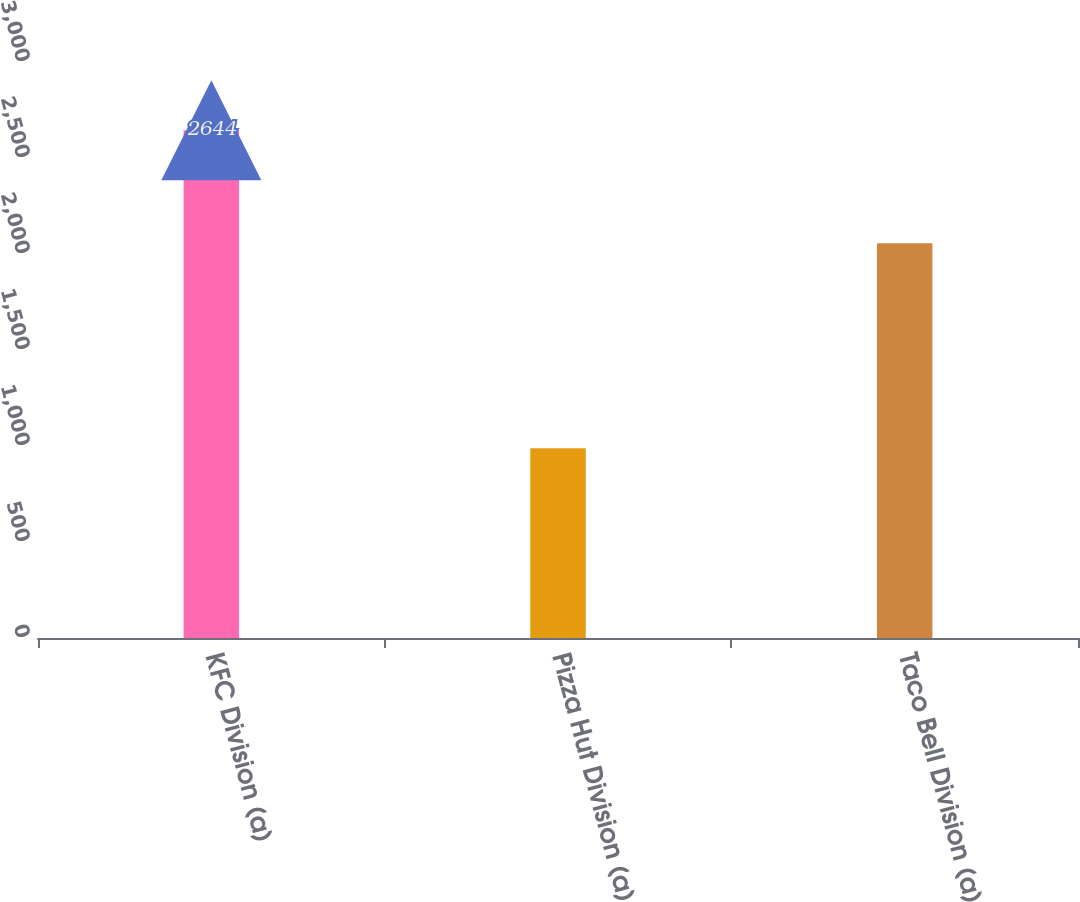<chart> <loc_0><loc_0><loc_500><loc_500><bar_chart><fcel>KFC Division (a)<fcel>Pizza Hut Division (a)<fcel>Taco Bell Division (a)<nl><fcel>2644<fcel>988<fcel>2056<nl></chart> 